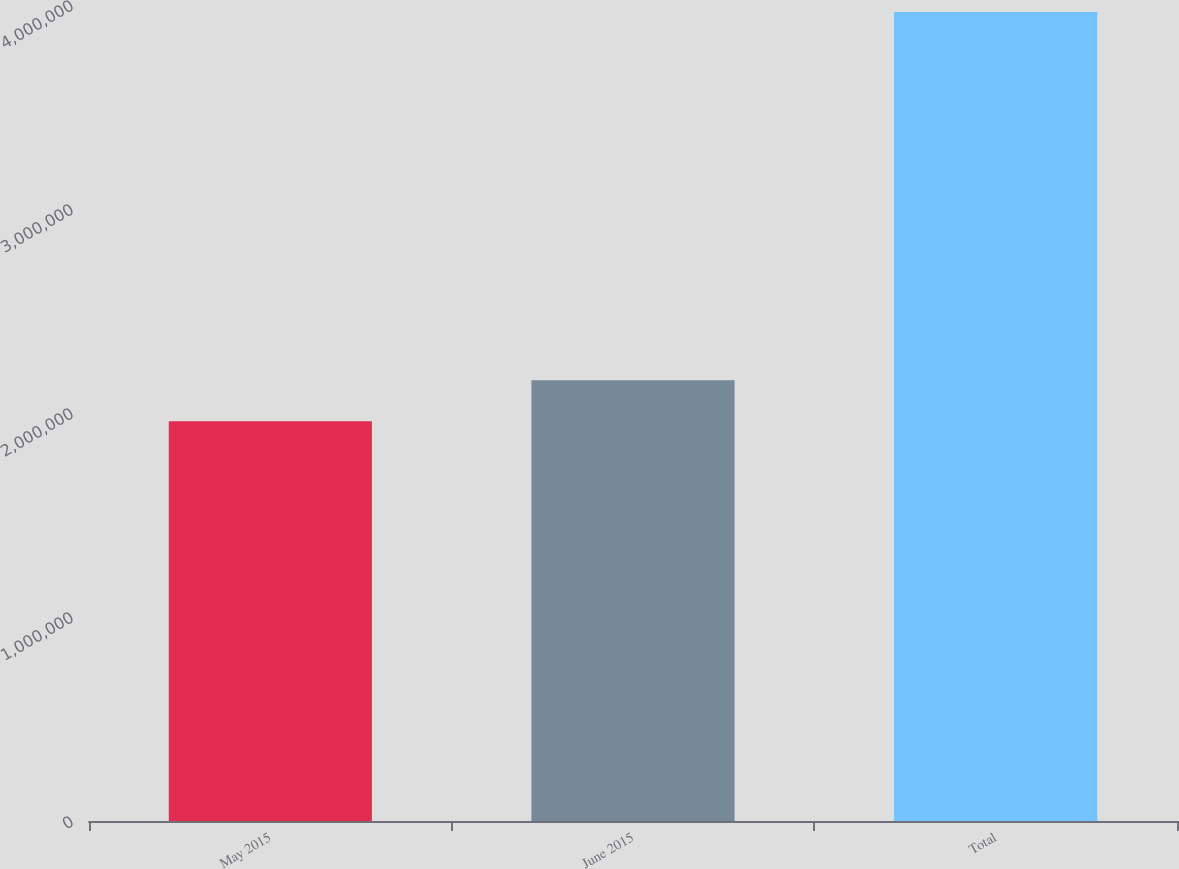Convert chart to OTSL. <chart><loc_0><loc_0><loc_500><loc_500><bar_chart><fcel>May 2015<fcel>June 2015<fcel>Total<nl><fcel>1.95956e+06<fcel>2.16021e+06<fcel>3.96602e+06<nl></chart> 